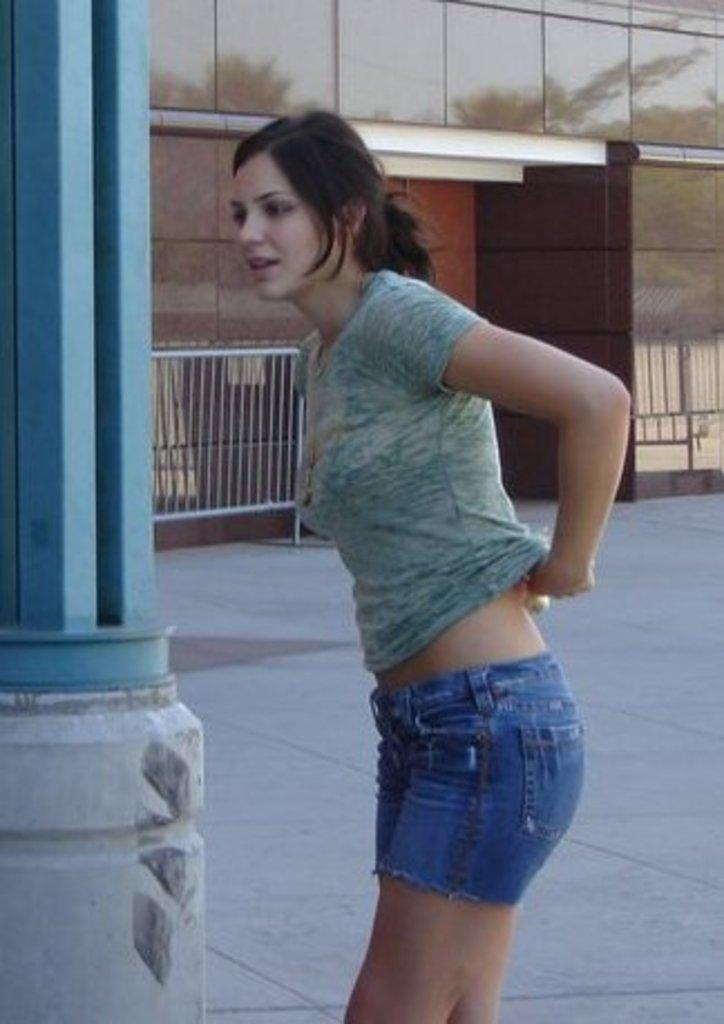What is the main subject in the image? There is a woman standing in the image. Where is the woman standing? The woman is standing on the floor. What can be seen on the left side of the image? There is a pillar on the left side of the image. What architectural features are visible in the background? There is a railing and a wall in the background of the image. What type of substance is the woman holding in her ear in the image? There is no substance visible in or mentioned in the woman's ear in the image. 